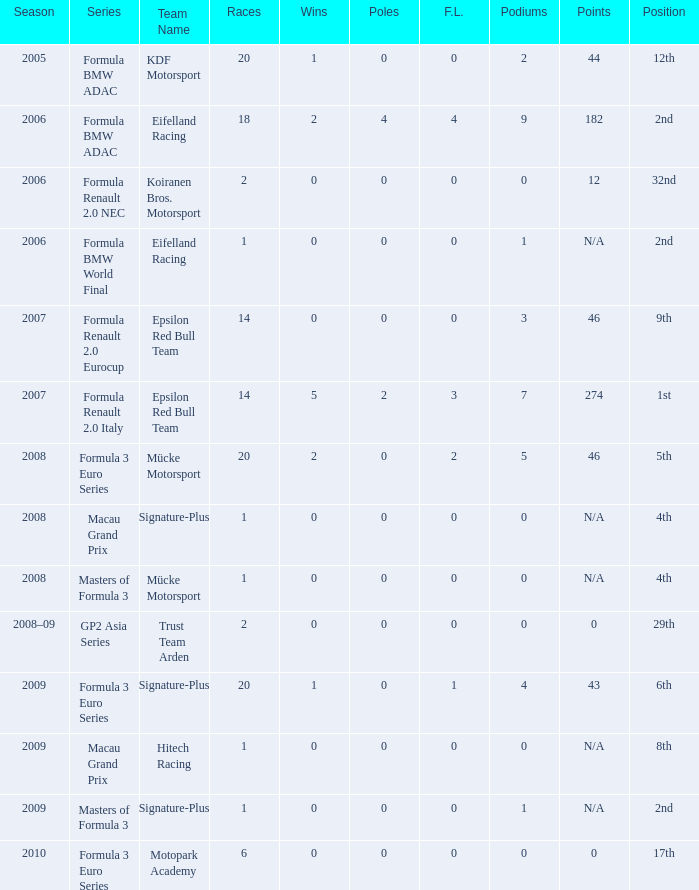What is the typical number of podiums in the 32nd place with under 0 wins? None. 